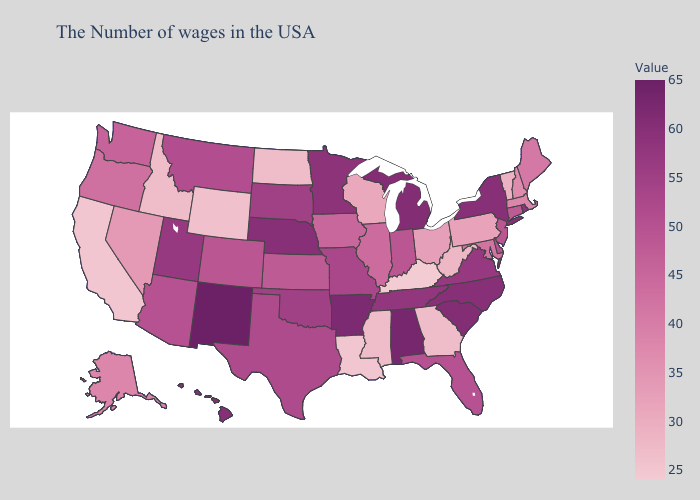Does Montana have a higher value than South Carolina?
Write a very short answer. No. Which states have the lowest value in the USA?
Short answer required. Kentucky. Does the map have missing data?
Give a very brief answer. No. Does Alabama have the highest value in the South?
Short answer required. Yes. 